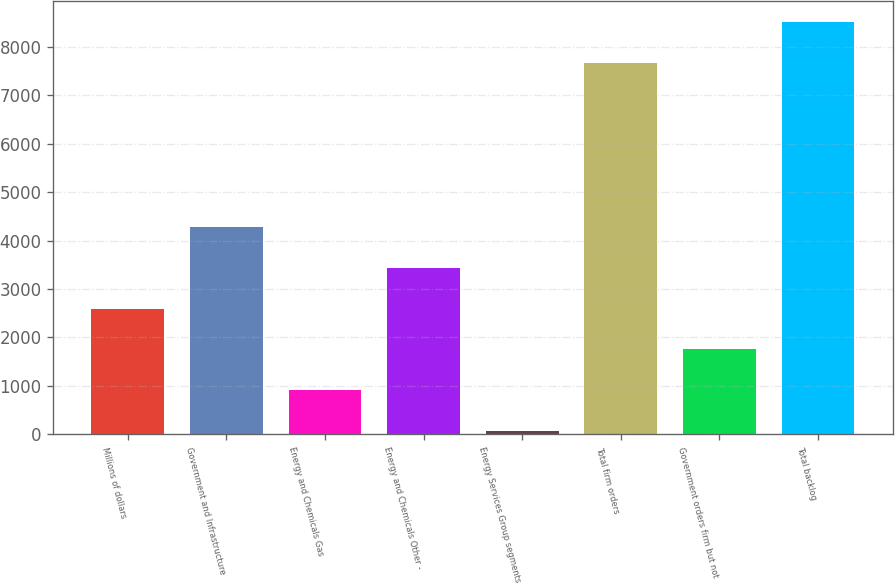Convert chart to OTSL. <chart><loc_0><loc_0><loc_500><loc_500><bar_chart><fcel>Millions of dollars<fcel>Government and Infrastructure<fcel>Energy and Chemicals Gas<fcel>Energy and Chemicals Other -<fcel>Energy Services Group segments<fcel>Total firm orders<fcel>Government orders firm but not<fcel>Total backlog<nl><fcel>2592.1<fcel>4277.5<fcel>906.7<fcel>3434.8<fcel>64<fcel>7675<fcel>1749.4<fcel>8517.7<nl></chart> 